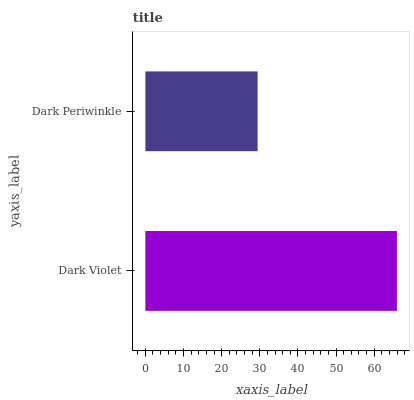Is Dark Periwinkle the minimum?
Answer yes or no. Yes. Is Dark Violet the maximum?
Answer yes or no. Yes. Is Dark Periwinkle the maximum?
Answer yes or no. No. Is Dark Violet greater than Dark Periwinkle?
Answer yes or no. Yes. Is Dark Periwinkle less than Dark Violet?
Answer yes or no. Yes. Is Dark Periwinkle greater than Dark Violet?
Answer yes or no. No. Is Dark Violet less than Dark Periwinkle?
Answer yes or no. No. Is Dark Violet the high median?
Answer yes or no. Yes. Is Dark Periwinkle the low median?
Answer yes or no. Yes. Is Dark Periwinkle the high median?
Answer yes or no. No. Is Dark Violet the low median?
Answer yes or no. No. 